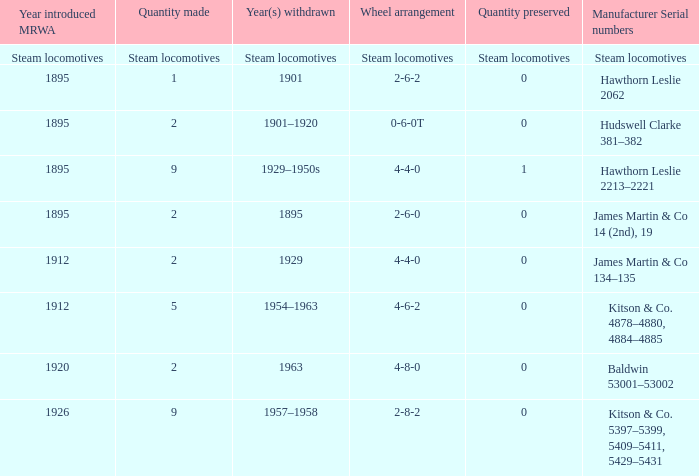Can you give me this table as a dict? {'header': ['Year introduced MRWA', 'Quantity made', 'Year(s) withdrawn', 'Wheel arrangement', 'Quantity preserved', 'Manufacturer Serial numbers'], 'rows': [['Steam locomotives', 'Steam locomotives', 'Steam locomotives', 'Steam locomotives', 'Steam locomotives', 'Steam locomotives'], ['1895', '1', '1901', '2-6-2', '0', 'Hawthorn Leslie 2062'], ['1895', '2', '1901–1920', '0-6-0T', '0', 'Hudswell Clarke 381–382'], ['1895', '9', '1929–1950s', '4-4-0', '1', 'Hawthorn Leslie 2213–2221'], ['1895', '2', '1895', '2-6-0', '0', 'James Martin & Co 14 (2nd), 19'], ['1912', '2', '1929', '4-4-0', '0', 'James Martin & Co 134–135'], ['1912', '5', '1954–1963', '4-6-2', '0', 'Kitson & Co. 4878–4880, 4884–4885'], ['1920', '2', '1963', '4-8-0', '0', 'Baldwin 53001–53002'], ['1926', '9', '1957–1958', '2-8-2', '0', 'Kitson & Co. 5397–5399, 5409–5411, 5429–5431']]} What is the manufacturer serial number of the 1963 withdrawn year? Baldwin 53001–53002. 